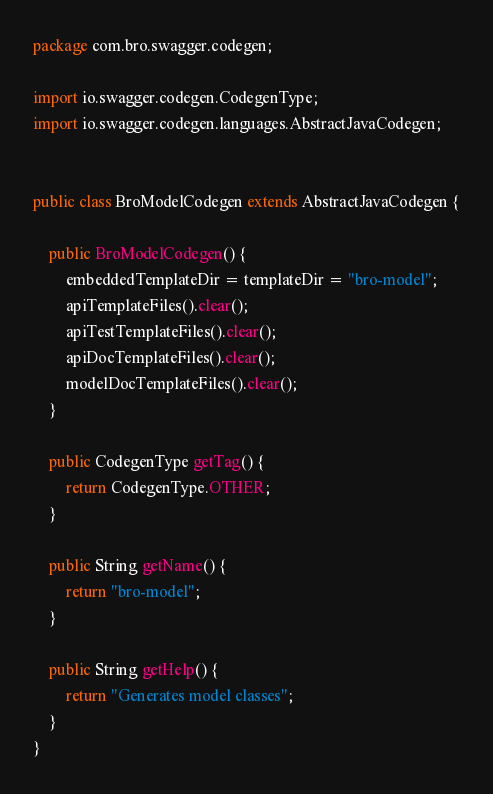<code> <loc_0><loc_0><loc_500><loc_500><_Java_>package com.bro.swagger.codegen;

import io.swagger.codegen.CodegenType;
import io.swagger.codegen.languages.AbstractJavaCodegen;


public class BroModelCodegen extends AbstractJavaCodegen {

    public BroModelCodegen() {
        embeddedTemplateDir = templateDir = "bro-model";
        apiTemplateFiles().clear();
        apiTestTemplateFiles().clear();
        apiDocTemplateFiles().clear();
        modelDocTemplateFiles().clear();
    }

    public CodegenType getTag() {
        return CodegenType.OTHER;
    }

    public String getName() {
        return "bro-model";
    }

    public String getHelp() {
        return "Generates model classes";
    }
}
</code> 